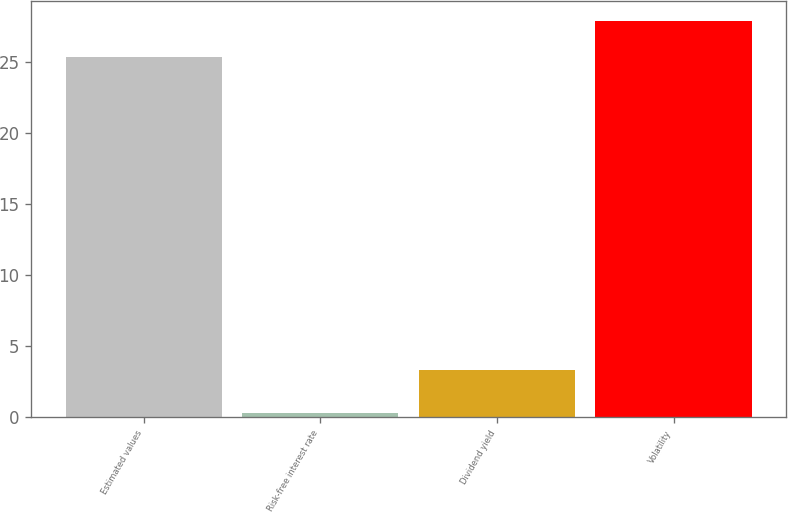Convert chart. <chart><loc_0><loc_0><loc_500><loc_500><bar_chart><fcel>Estimated values<fcel>Risk-free interest rate<fcel>Dividend yield<fcel>Volatility<nl><fcel>25.32<fcel>0.3<fcel>3.3<fcel>27.89<nl></chart> 